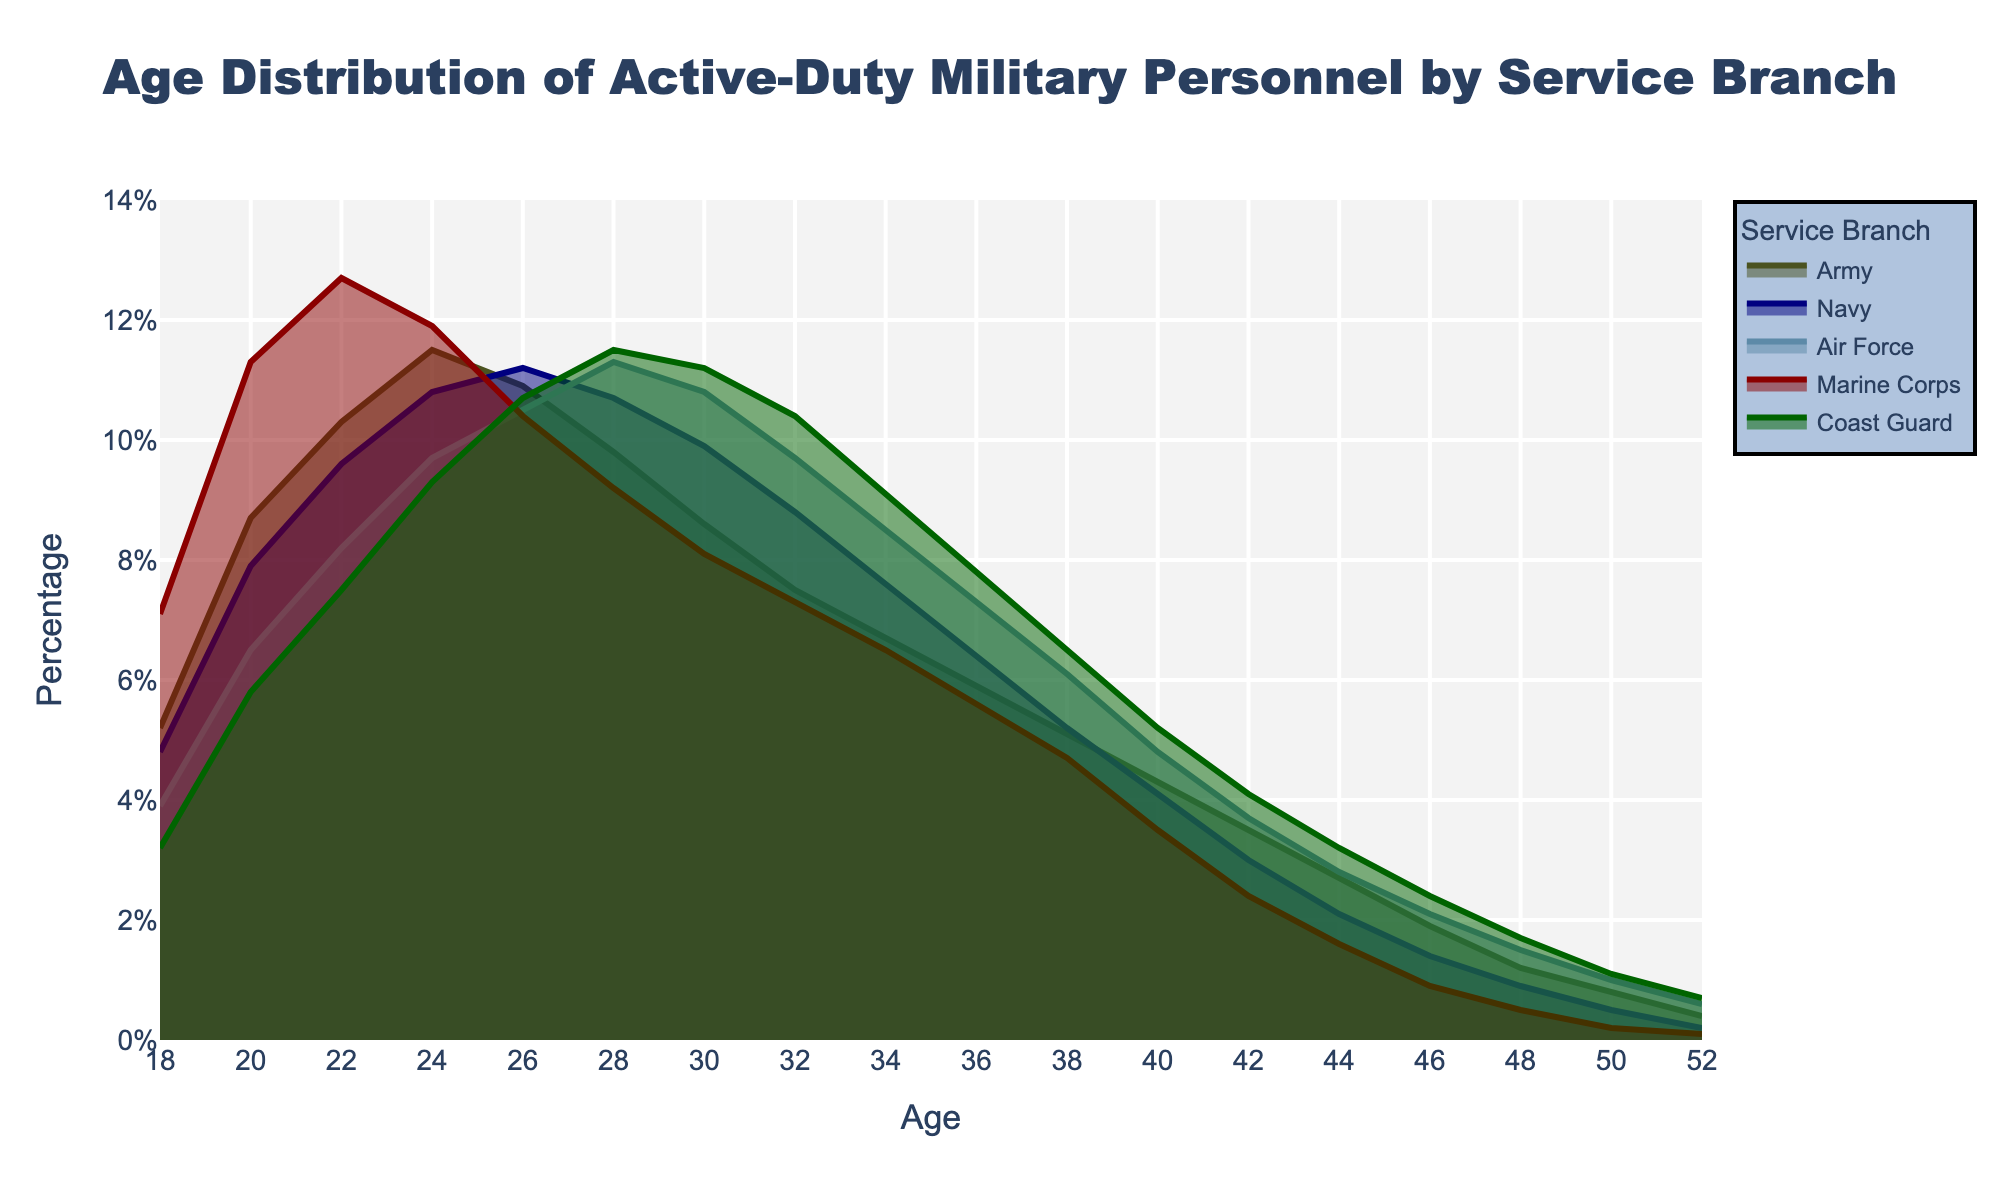what is the title of the figure? The title of the figure is located at the top center of the plot. It summarizes the information being presented in the figure.
Answer: Age Distribution of Active-Duty Military Personnel by Service Branch Which service branch has the highest percentage of personnel at age 24? By looking at the density plot, find the highest peak for age 24 across all branches.
Answer: Army At what age does the Air Force have the highest percentage of active-duty personnel? Locate the peak of the density plot line representing the Air Force and identify the corresponding age.
Answer: 28 What is the difference in the percentage of personnel between the Marine Corps and Coast Guard at age 20? Identify the percentage for both Marine Corps and Coast Guard at age 20 from the plot and calculate the difference.
Answer: 11.3% - 5.8% = 5.5% At what age does the total percentage of personnel for all branches collectively reach its peak? Sum the percentage values for each age across all branches, and identify the age with the highest total percentage. This is a more involved calculation requiring the addition of all the values for each age across branches.
Answer: 24 Which service branch has the widest age range span on the density plot? Determine the range of ages for each branch where the percentage is above zero, noting the minimum and maximum ages at which each branch's density line appears.
Answer: Coast Guard Between ages 30 and 34, which branch sees the steepest decline in the percentage of personnel? Evaluate the slope of the density plots between ages 30 and 34 for each branch and identify the branch with the greatest decrease in percentage.
Answer: Navy What is the percentage of personnel for the Navy at age 18 and how does it compare to the Army? Identify the percentage for the Navy and the Army at age 18 from the density plot and compare them.
Answer: Navy: 4.8%, Army: 5.2%, Army is higher by 0.4% Which service branch shows a consistent decline in the percentage of personnel after age 28 without any increases? Analyze the density plots of each branch starting from age 28 and identify which plot shows a continuous downward trend with no upward movements.
Answer: Marine Corps What is the percentage difference between the youngest (18) and the oldest (52) age groups in the Army? Look at the percentage of Army personnel at age 18 and age 52, then calculate the difference.
Answer: 5.2% - 0.4% = 4.8% 